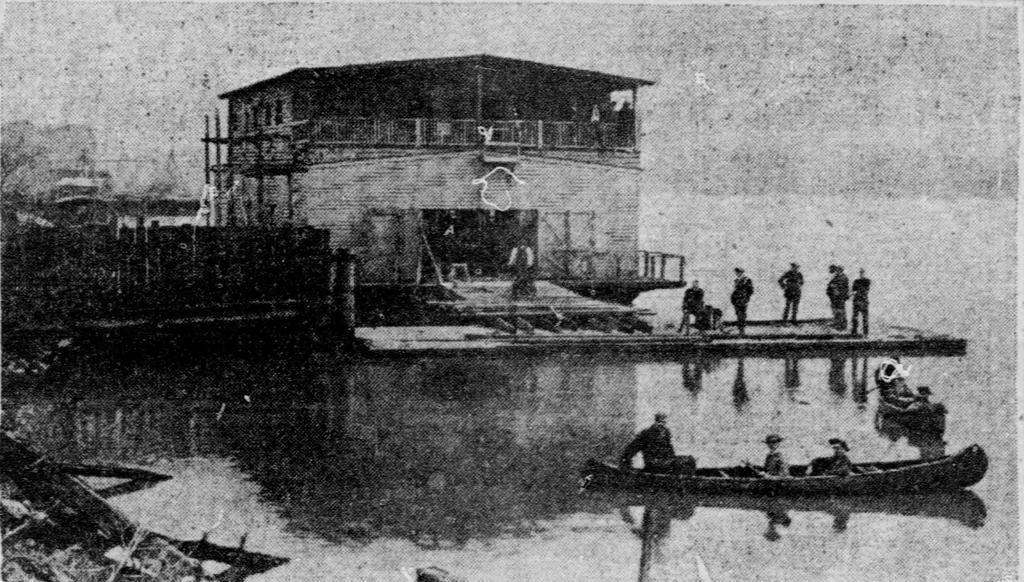Please provide a concise description of this image. In the image we can see a boat in the water, there are people sitting in the boat. We can even see there are people standing, this is a fence, sky and a wooden building. 